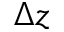<formula> <loc_0><loc_0><loc_500><loc_500>\Delta z</formula> 